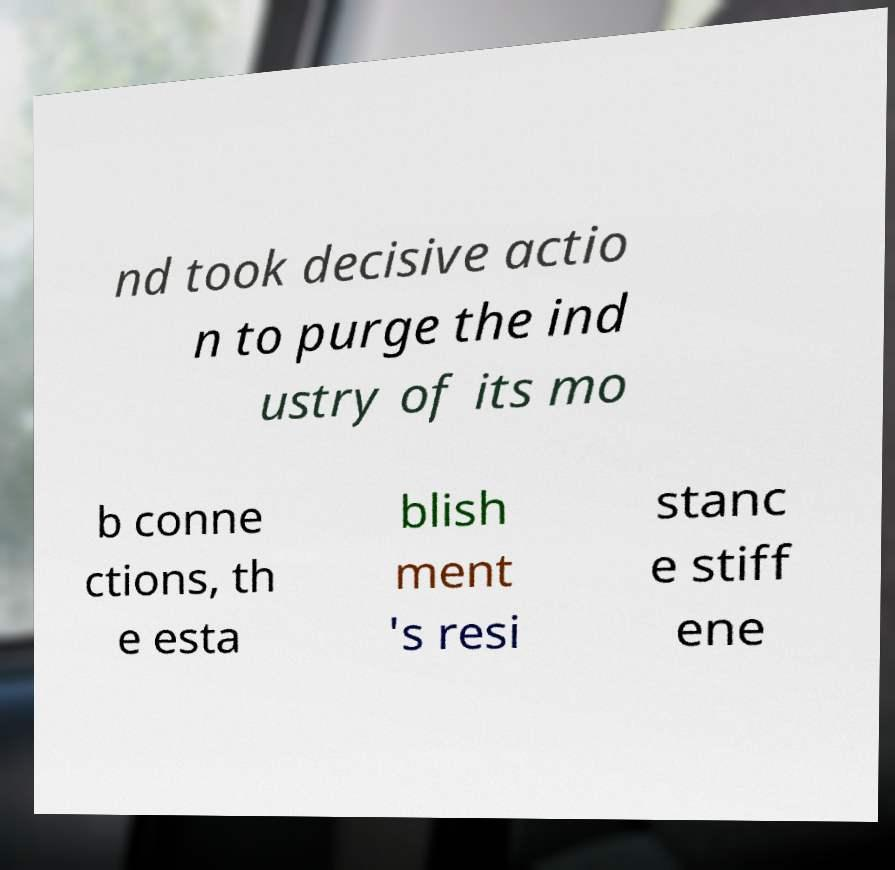Please read and relay the text visible in this image. What does it say? nd took decisive actio n to purge the ind ustry of its mo b conne ctions, th e esta blish ment 's resi stanc e stiff ene 